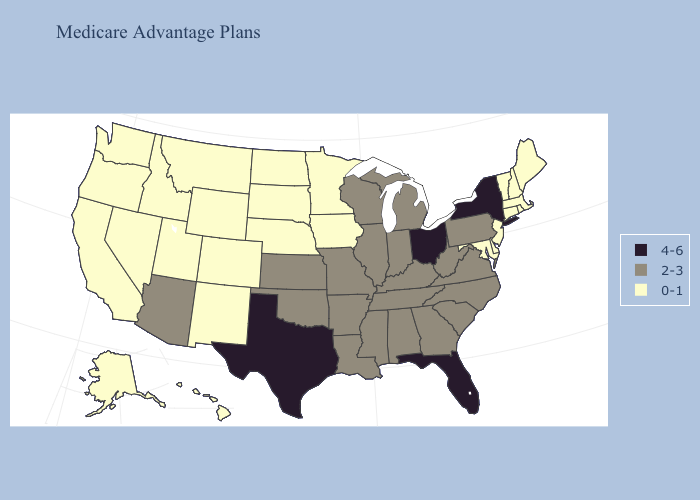Does Delaware have the lowest value in the South?
Keep it brief. Yes. Does California have the same value as New York?
Short answer required. No. Does Kansas have a lower value than New York?
Quick response, please. Yes. Does the first symbol in the legend represent the smallest category?
Keep it brief. No. Name the states that have a value in the range 4-6?
Be succinct. Florida, New York, Ohio, Texas. Which states hav the highest value in the South?
Answer briefly. Florida, Texas. Does New Hampshire have the lowest value in the Northeast?
Answer briefly. Yes. Which states have the highest value in the USA?
Quick response, please. Florida, New York, Ohio, Texas. Does Virginia have the same value as South Carolina?
Write a very short answer. Yes. Among the states that border Wisconsin , does Iowa have the lowest value?
Concise answer only. Yes. Name the states that have a value in the range 0-1?
Quick response, please. Alaska, California, Colorado, Connecticut, Delaware, Hawaii, Iowa, Idaho, Massachusetts, Maryland, Maine, Minnesota, Montana, North Dakota, Nebraska, New Hampshire, New Jersey, New Mexico, Nevada, Oregon, Rhode Island, South Dakota, Utah, Vermont, Washington, Wyoming. Does Wyoming have the same value as Missouri?
Give a very brief answer. No. Among the states that border Alabama , which have the lowest value?
Answer briefly. Georgia, Mississippi, Tennessee. Among the states that border Wyoming , which have the highest value?
Answer briefly. Colorado, Idaho, Montana, Nebraska, South Dakota, Utah. Name the states that have a value in the range 0-1?
Keep it brief. Alaska, California, Colorado, Connecticut, Delaware, Hawaii, Iowa, Idaho, Massachusetts, Maryland, Maine, Minnesota, Montana, North Dakota, Nebraska, New Hampshire, New Jersey, New Mexico, Nevada, Oregon, Rhode Island, South Dakota, Utah, Vermont, Washington, Wyoming. 